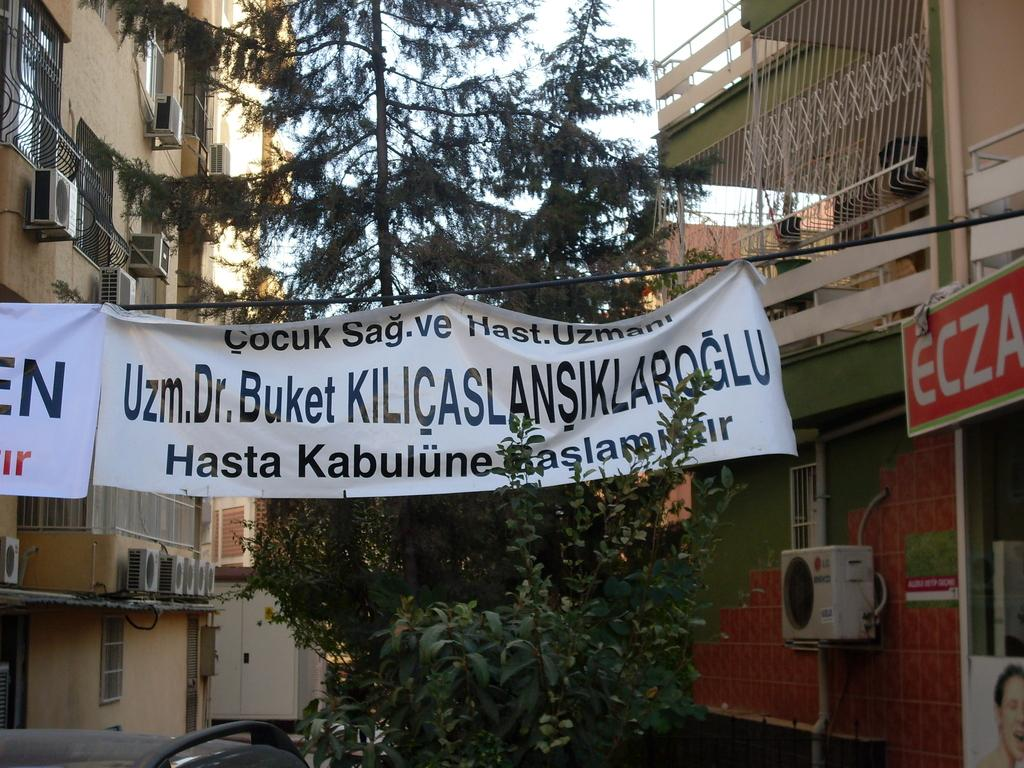What can be seen hanging in the picture? There are banners in the picture. What is written on the banners? The banners have writing on them. What can be seen in the distance in the picture? There are trees, buildings, and the sky visible in the background of the picture. What other objects can be seen in the background of the picture? There are other objects in the background of the picture. How many ants can be seen crawling on the banners in the image? There are no ants present in the image, as it features banners with writing and a background with trees, buildings, and the sky. 